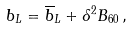Convert formula to latex. <formula><loc_0><loc_0><loc_500><loc_500>b _ { L } = \overline { b } _ { L } + \delta ^ { 2 } B _ { 6 0 } \, ,</formula> 